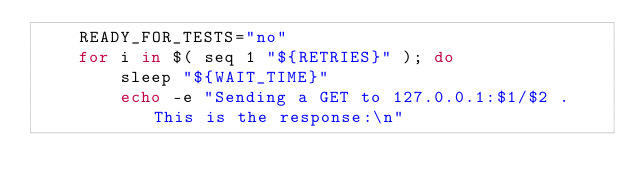<code> <loc_0><loc_0><loc_500><loc_500><_Bash_>    READY_FOR_TESTS="no"
    for i in $( seq 1 "${RETRIES}" ); do
        sleep "${WAIT_TIME}"
        echo -e "Sending a GET to 127.0.0.1:$1/$2 . This is the response:\n"</code> 